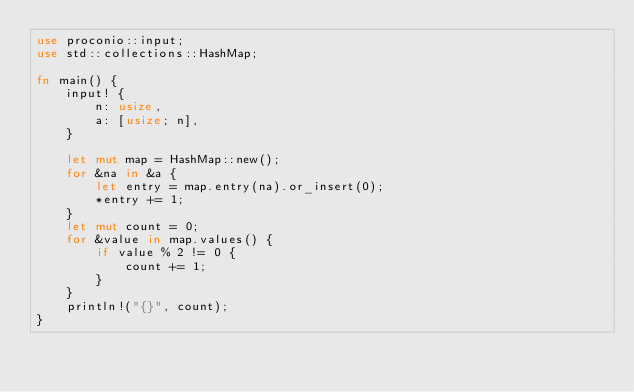<code> <loc_0><loc_0><loc_500><loc_500><_Rust_>use proconio::input;
use std::collections::HashMap;

fn main() {
    input! {
        n: usize,
        a: [usize; n],
    }

    let mut map = HashMap::new();
    for &na in &a {
        let entry = map.entry(na).or_insert(0);
        *entry += 1;
    }
    let mut count = 0;
    for &value in map.values() {
        if value % 2 != 0 {
            count += 1;
        }
    }
    println!("{}", count);
}
</code> 